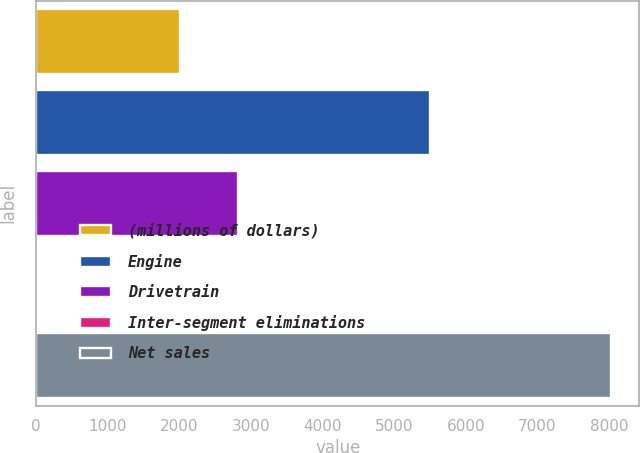Convert chart to OTSL. <chart><loc_0><loc_0><loc_500><loc_500><bar_chart><fcel>(millions of dollars)<fcel>Engine<fcel>Drivetrain<fcel>Inter-segment eliminations<fcel>Net sales<nl><fcel>2015<fcel>5500<fcel>2813.97<fcel>33.5<fcel>8023.2<nl></chart> 